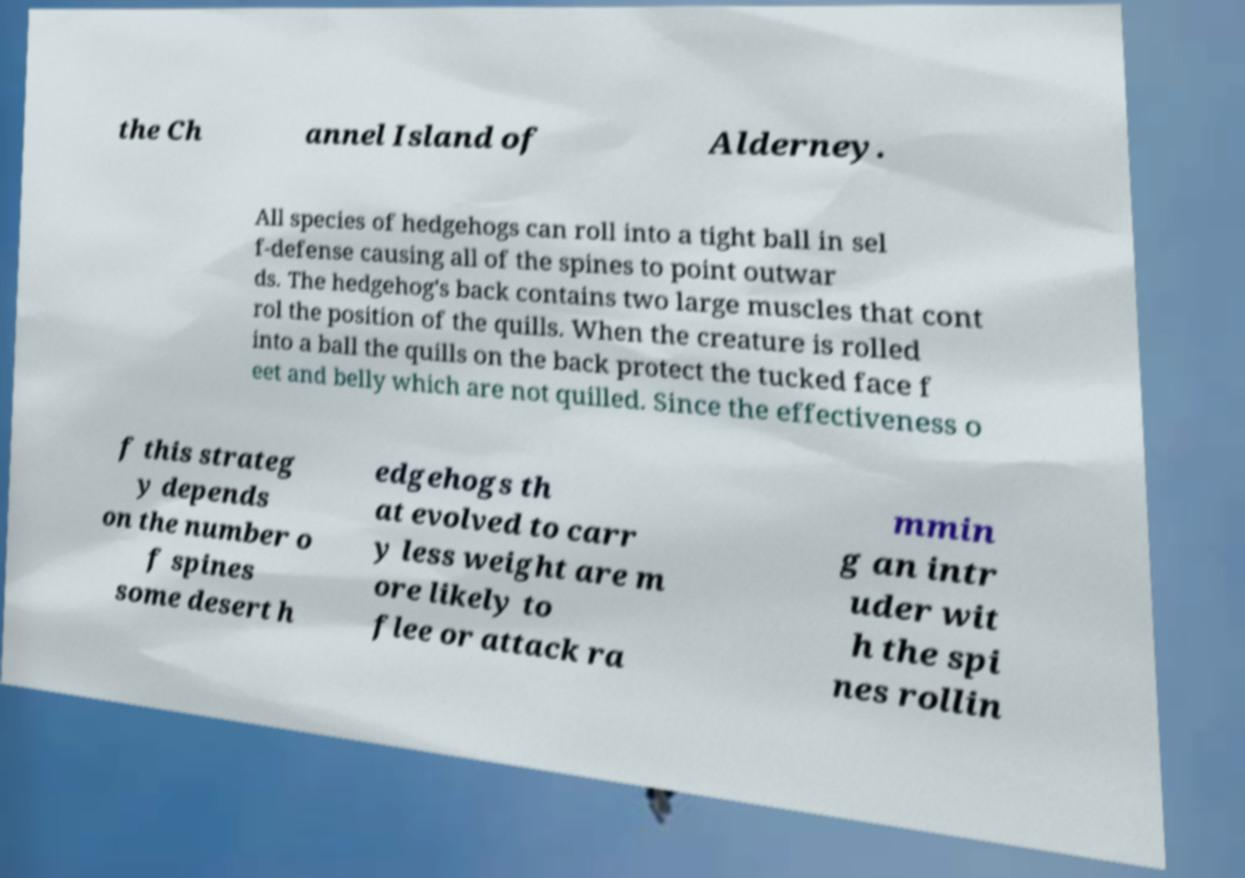For documentation purposes, I need the text within this image transcribed. Could you provide that? the Ch annel Island of Alderney. All species of hedgehogs can roll into a tight ball in sel f-defense causing all of the spines to point outwar ds. The hedgehog's back contains two large muscles that cont rol the position of the quills. When the creature is rolled into a ball the quills on the back protect the tucked face f eet and belly which are not quilled. Since the effectiveness o f this strateg y depends on the number o f spines some desert h edgehogs th at evolved to carr y less weight are m ore likely to flee or attack ra mmin g an intr uder wit h the spi nes rollin 